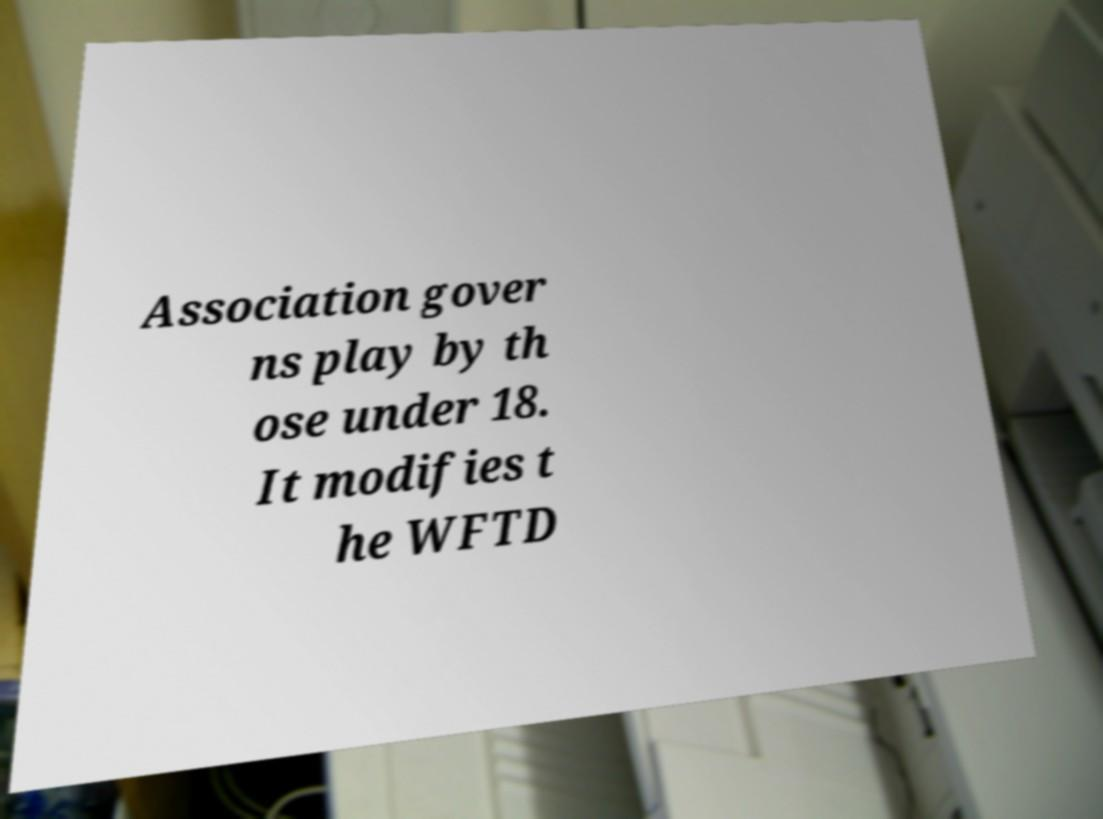Could you assist in decoding the text presented in this image and type it out clearly? Association gover ns play by th ose under 18. It modifies t he WFTD 